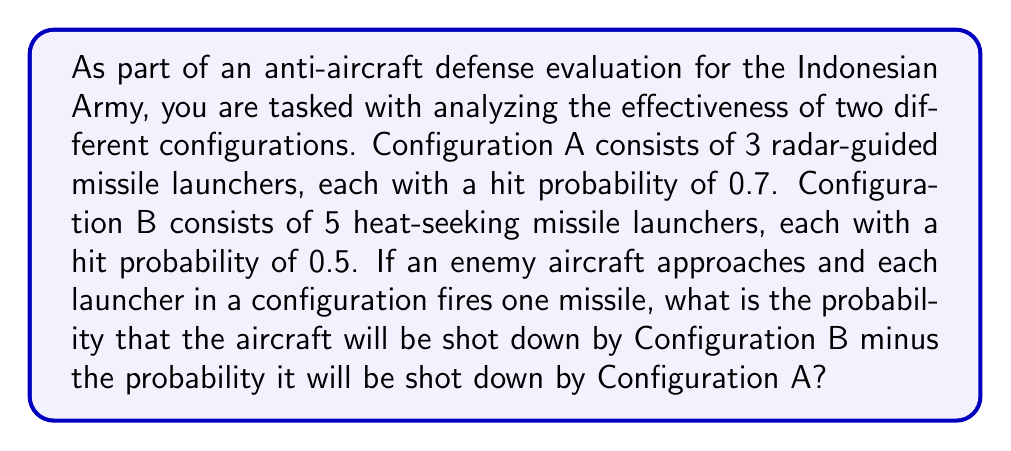What is the answer to this math problem? Let's approach this step-by-step:

1) For Configuration A:
   - Probability of a single launcher hitting = 0.7
   - Probability of a single launcher missing = 1 - 0.7 = 0.3
   - Probability of all 3 launchers missing = $0.3^3 = 0.027$
   - Probability of at least one launcher hitting (aircraft shot down) = $1 - 0.027 = 0.973$

2) For Configuration B:
   - Probability of a single launcher hitting = 0.5
   - Probability of a single launcher missing = 1 - 0.5 = 0.5
   - Probability of all 5 launchers missing = $0.5^5 = 0.03125$
   - Probability of at least one launcher hitting (aircraft shot down) = $1 - 0.03125 = 0.96875$

3) The question asks for the probability of Configuration B minus Configuration A:
   $0.96875 - 0.973 = -0.00425$
Answer: $-0.00425$ or $-0.425\%$ 